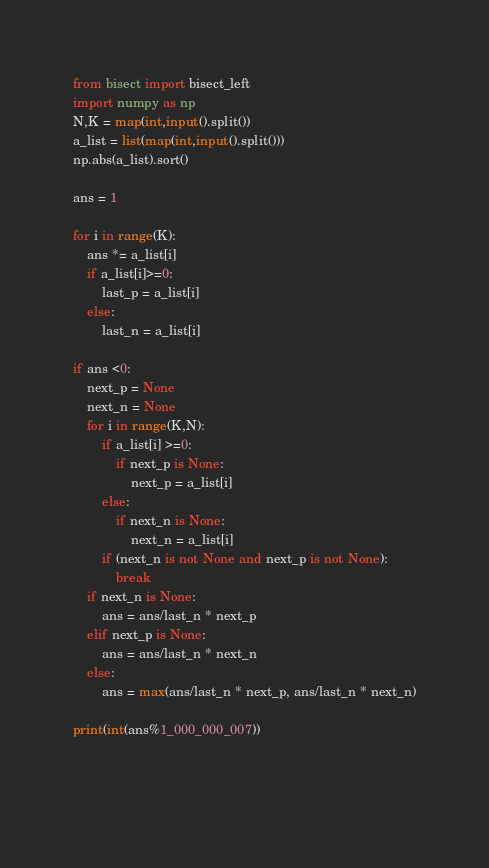<code> <loc_0><loc_0><loc_500><loc_500><_Python_>from bisect import bisect_left
import numpy as np
N,K = map(int,input().split())
a_list = list(map(int,input().split()))
np.abs(a_list).sort()

ans = 1

for i in range(K):
    ans *= a_list[i]
    if a_list[i]>=0:
        last_p = a_list[i]
    else:
        last_n = a_list[i]

if ans <0:
    next_p = None
    next_n = None
    for i in range(K,N):
        if a_list[i] >=0:
            if next_p is None:
                next_p = a_list[i]
        else:
            if next_n is None:
                next_n = a_list[i]
        if (next_n is not None and next_p is not None):
            break
    if next_n is None:
        ans = ans/last_n * next_p
    elif next_p is None:
        ans = ans/last_n * next_n
    else:
        ans = max(ans/last_n * next_p, ans/last_n * next_n)
    
print(int(ans%1_000_000_007))


        </code> 